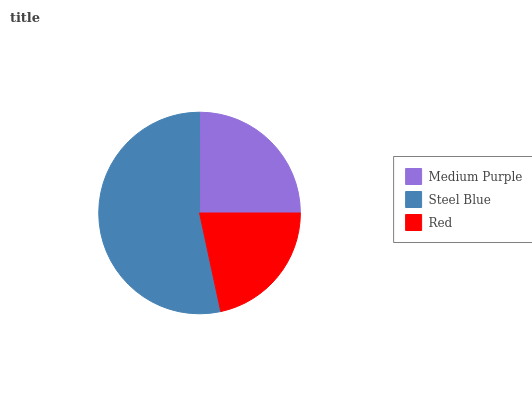Is Red the minimum?
Answer yes or no. Yes. Is Steel Blue the maximum?
Answer yes or no. Yes. Is Steel Blue the minimum?
Answer yes or no. No. Is Red the maximum?
Answer yes or no. No. Is Steel Blue greater than Red?
Answer yes or no. Yes. Is Red less than Steel Blue?
Answer yes or no. Yes. Is Red greater than Steel Blue?
Answer yes or no. No. Is Steel Blue less than Red?
Answer yes or no. No. Is Medium Purple the high median?
Answer yes or no. Yes. Is Medium Purple the low median?
Answer yes or no. Yes. Is Red the high median?
Answer yes or no. No. Is Steel Blue the low median?
Answer yes or no. No. 